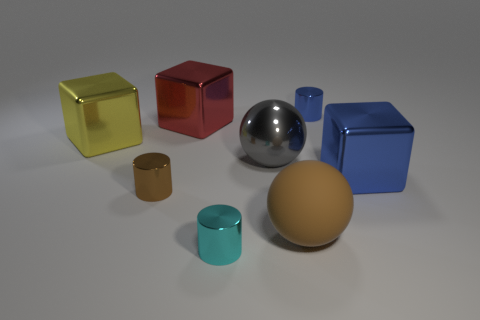Add 2 large rubber objects. How many objects exist? 10 Subtract 1 gray balls. How many objects are left? 7 Subtract all cylinders. How many objects are left? 5 Subtract all blue matte spheres. Subtract all tiny brown metallic cylinders. How many objects are left? 7 Add 6 blue blocks. How many blue blocks are left? 7 Add 7 red metallic blocks. How many red metallic blocks exist? 8 